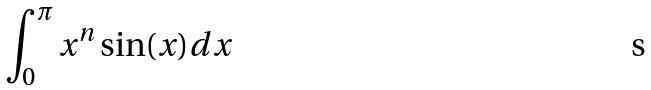Convert formula to latex. <formula><loc_0><loc_0><loc_500><loc_500>\int _ { 0 } ^ { \pi } x ^ { n } \sin ( x ) d x</formula> 